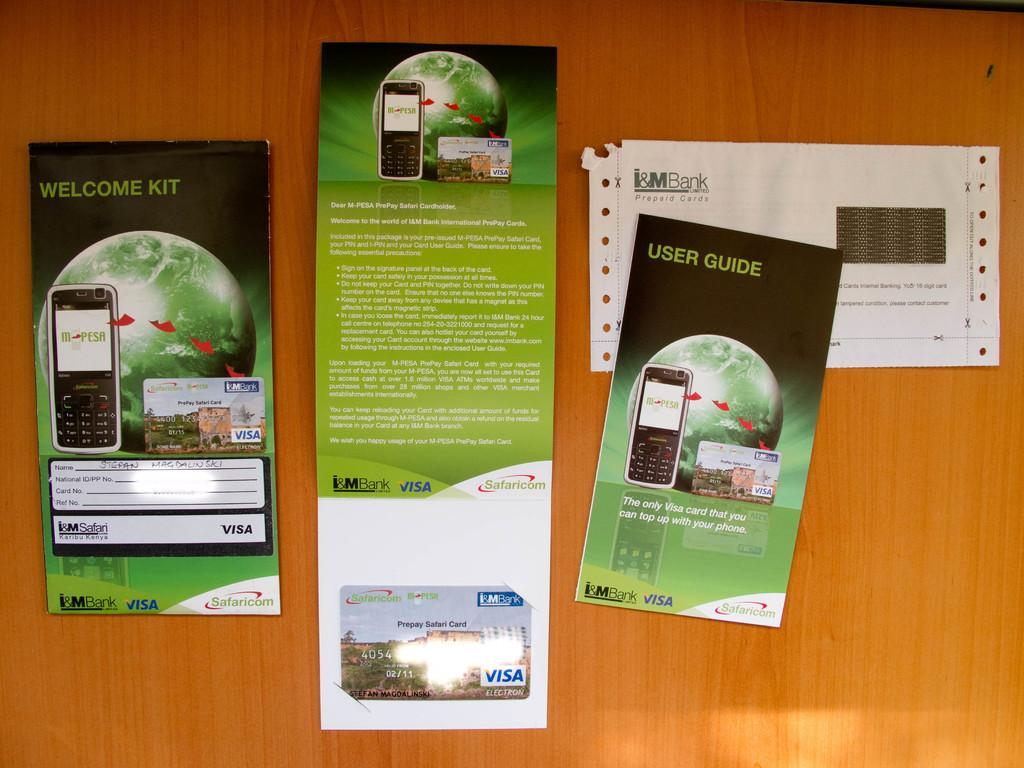Provide a one-sentence caption for the provided image. User guide and welcome kit for a visa card. 